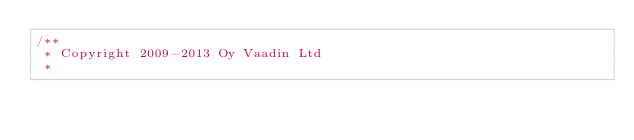<code> <loc_0><loc_0><loc_500><loc_500><_Java_>/**
 * Copyright 2009-2013 Oy Vaadin Ltd
 *</code> 